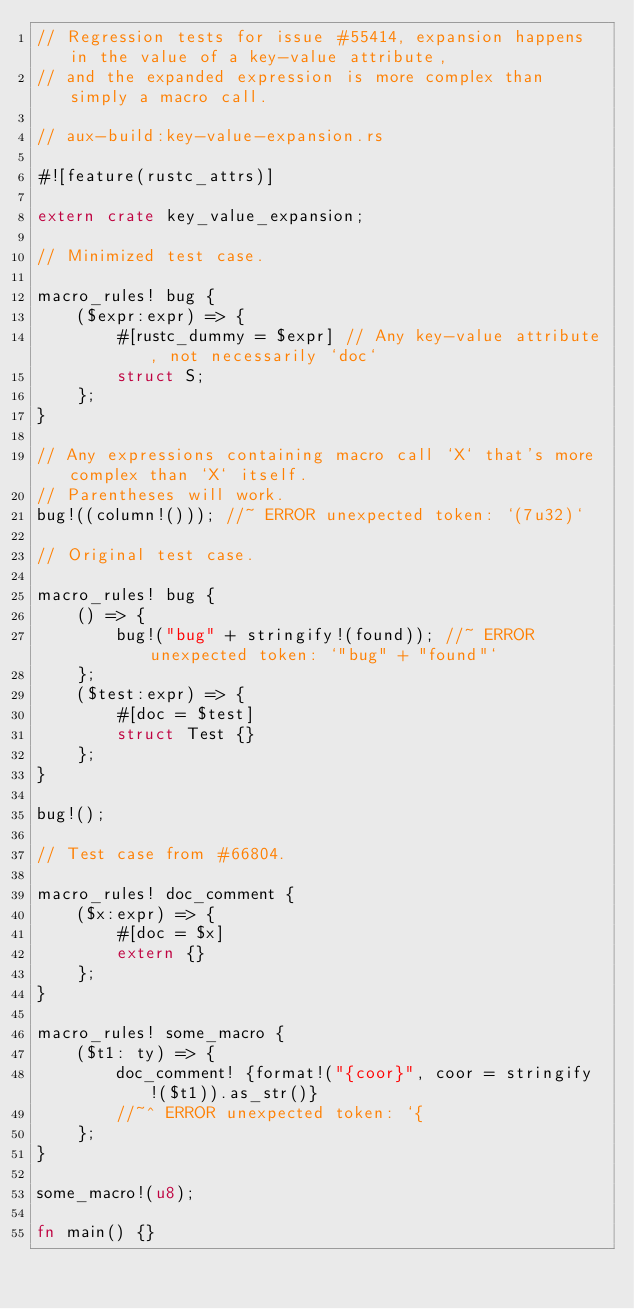<code> <loc_0><loc_0><loc_500><loc_500><_Rust_>// Regression tests for issue #55414, expansion happens in the value of a key-value attribute,
// and the expanded expression is more complex than simply a macro call.

// aux-build:key-value-expansion.rs

#![feature(rustc_attrs)]

extern crate key_value_expansion;

// Minimized test case.

macro_rules! bug {
    ($expr:expr) => {
        #[rustc_dummy = $expr] // Any key-value attribute, not necessarily `doc`
        struct S;
    };
}

// Any expressions containing macro call `X` that's more complex than `X` itself.
// Parentheses will work.
bug!((column!())); //~ ERROR unexpected token: `(7u32)`

// Original test case.

macro_rules! bug {
    () => {
        bug!("bug" + stringify!(found)); //~ ERROR unexpected token: `"bug" + "found"`
    };
    ($test:expr) => {
        #[doc = $test]
        struct Test {}
    };
}

bug!();

// Test case from #66804.

macro_rules! doc_comment {
    ($x:expr) => {
        #[doc = $x]
        extern {}
    };
}

macro_rules! some_macro {
    ($t1: ty) => {
        doc_comment! {format!("{coor}", coor = stringify!($t1)).as_str()}
        //~^ ERROR unexpected token: `{
    };
}

some_macro!(u8);

fn main() {}
</code> 